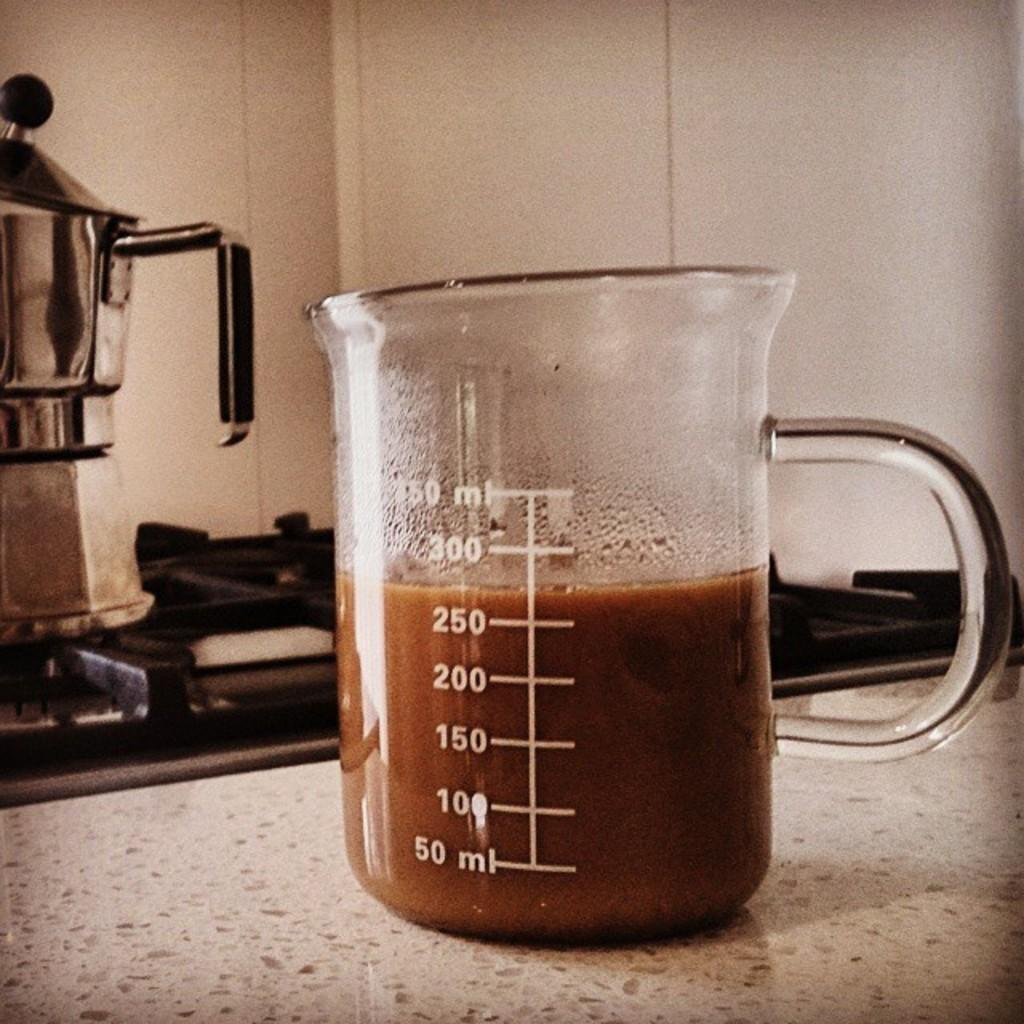<image>
Relay a brief, clear account of the picture shown. a clear glass pitcher has 275 ml of brown liquid in it 